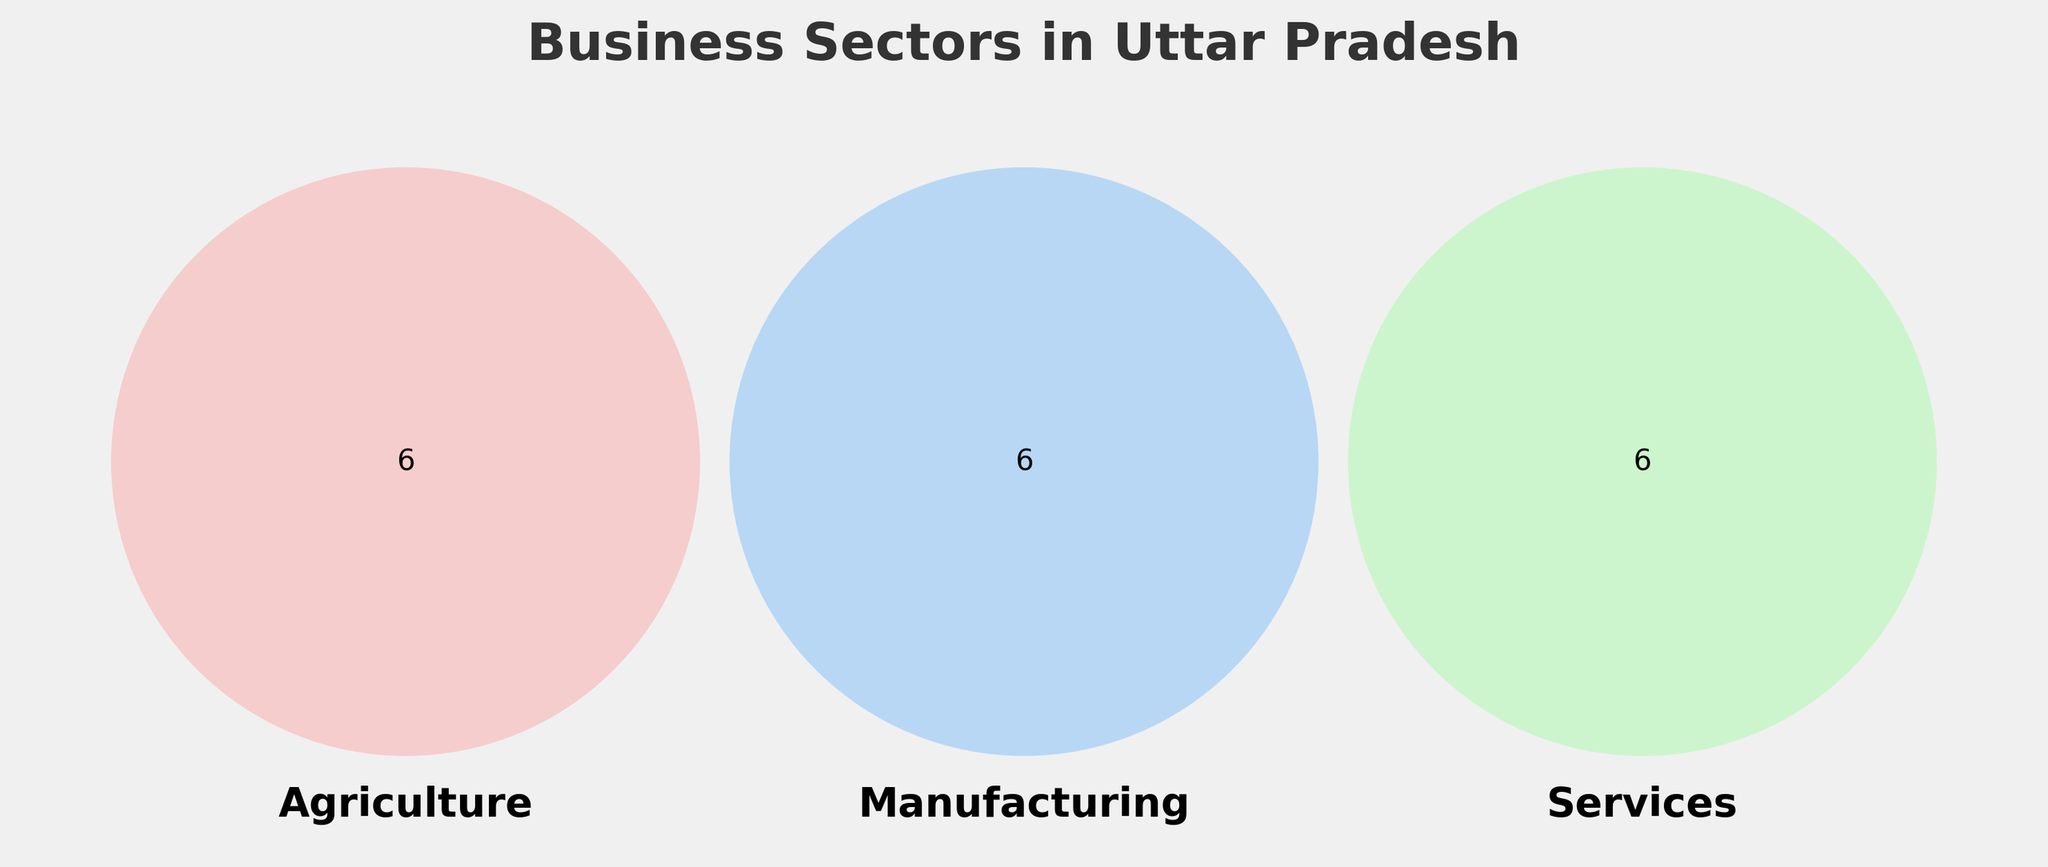What's the title of the Venn Diagram? The title of the Venn Diagram is "Business Sectors in Uttar Pradesh", which is shown at the top of the figure.
Answer: Business Sectors in Uttar Pradesh How many business sectors are represented in the Agriculture category? The business sectors represented in the Agriculture category are Wheat, Sugarcane, Rice, Livestock, Dairy, and Potatoes. Counting these, we get 6 sectors.
Answer: 6 Which sector is only in the Services category but not in Agriculture or Manufacturing? From the diagram, IT, Healthcare, Tourism, Education, Real estate, and Banking are in the Services category. Among these, none of them overlap with Agriculture or Manufacturing.
Answer: IT, Healthcare, Tourism, Education, Real estate, Banking Which business sectors are common to both Manufacturing and Services? None of the sectors overlap between Manufacturing (Leather goods, Textiles, Handicrafts, Cement, Carpets, Glassware) and Services (IT, Healthcare, Tourism, Education, Real estate, Banking).
Answer: None What is the color representing the Manufacturing category in the Venn Diagram? The Manufacturing category is represented by blue color in the Venn Diagram.
Answer: Blue Are there any sectors that fall under all three categories: Agriculture, Manufacturing, and Services? There are no sectors that fall under all three categories as per the Venn Diagram.
Answer: No Which category has the sector 'Rice'? According to the Venn Diagram, 'Rice' falls under the Agriculture category.
Answer: Agriculture Compare the number of sectors in Agriculture to Services. Which has more? Agriculture has 6 sectors (Wheat, Sugarcane, Rice, Livestock, Dairy, Potatoes), and Services also have 6 sectors (IT, Healthcare, Tourism, Education, Real estate, Banking). Thus, both categories have an equal number of sectors.
Answer: Equal How many sectors does Manufacturing have that are not common to Services? All the sectors in Manufacturing (Leather goods, Textiles, Handicrafts, Cement, Carpets, Glassware) are not common to Services. So, it has 6 sectors in total.
Answer: 6 What sector in the diagram is linked to Uttar Pradesh’s Tourism industry? The Tourism sector is directly mentioned under the Services category in the Venn Diagram.
Answer: Tourism 